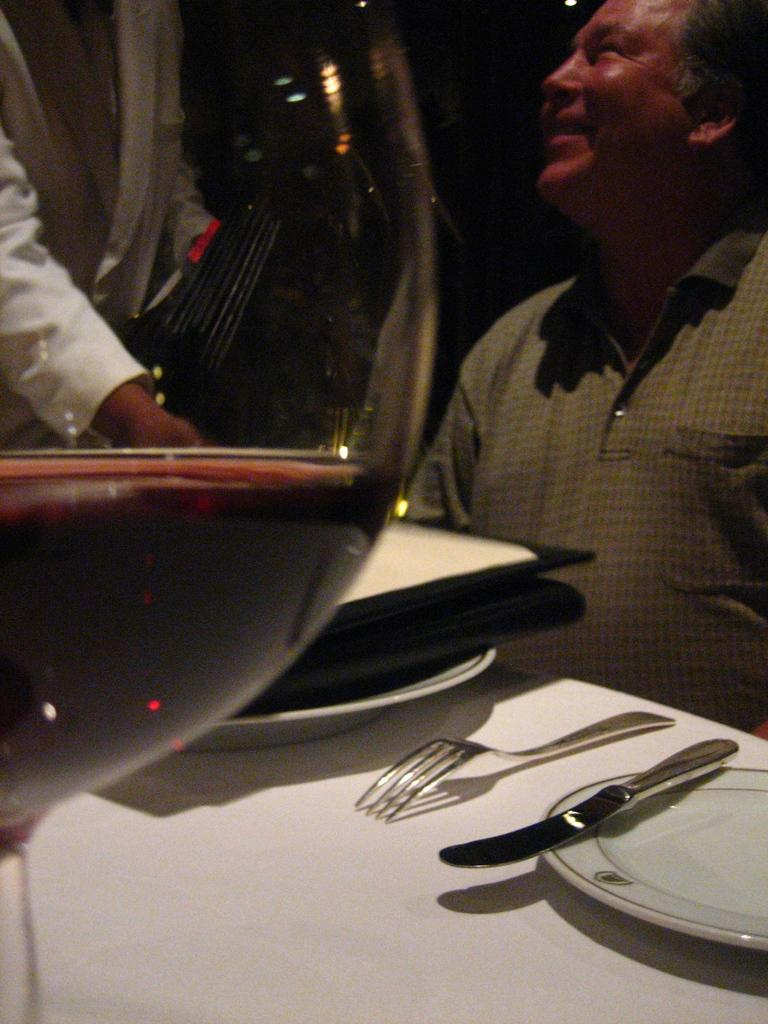What is present on the table in the image? There are plates and spoons on the table in the image. What can be seen to the right of the table? There is a person sitting to the right in the image. What is the person holding or using in the image? The person is not holding or using anything visible in the image. What is the main object in the image? There is a wine glass in the image. What time does the school bell ring for recess in the image? There is no school bell or recess present in the image. How does the person in the image control the situation? The person in the image is not controlling any situation, as they are not holding or using anything visible. 